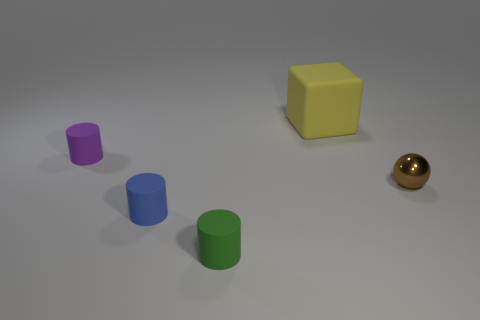What is the shape of the thing that is right of the tiny green cylinder and behind the brown shiny object?
Ensure brevity in your answer.  Cube. What number of other things are there of the same color as the big rubber cube?
Give a very brief answer. 0. What is the shape of the tiny blue matte thing?
Give a very brief answer. Cylinder. The small thing that is behind the tiny thing on the right side of the green rubber thing is what color?
Give a very brief answer. Purple. Does the shiny ball have the same color as the cylinder that is behind the tiny blue matte thing?
Offer a terse response. No. What material is the cylinder that is both behind the tiny green matte cylinder and in front of the small purple object?
Your answer should be compact. Rubber. Are there any brown shiny balls that have the same size as the green cylinder?
Make the answer very short. Yes. What is the material of the blue object that is the same size as the metallic ball?
Keep it short and to the point. Rubber. There is a blue rubber cylinder; how many blue objects are left of it?
Your response must be concise. 0. There is a thing that is right of the large yellow cube; is its shape the same as the blue matte thing?
Your answer should be very brief. No. 